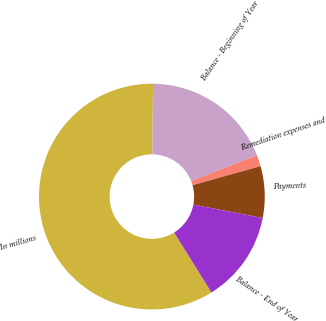<chart> <loc_0><loc_0><loc_500><loc_500><pie_chart><fcel>In millions<fcel>Balance - Beginning of Year<fcel>Remediation expenses and<fcel>Payments<fcel>Balance - End of Year<nl><fcel>59.01%<fcel>18.85%<fcel>1.64%<fcel>7.38%<fcel>13.12%<nl></chart> 